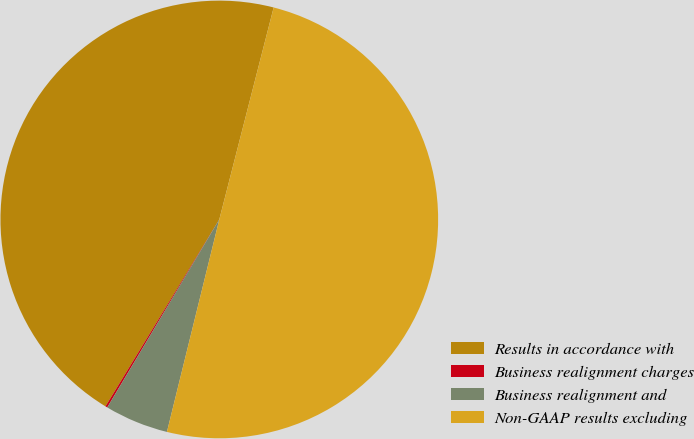<chart> <loc_0><loc_0><loc_500><loc_500><pie_chart><fcel>Results in accordance with<fcel>Business realignment charges<fcel>Business realignment and<fcel>Non-GAAP results excluding<nl><fcel>45.29%<fcel>0.15%<fcel>4.71%<fcel>49.85%<nl></chart> 